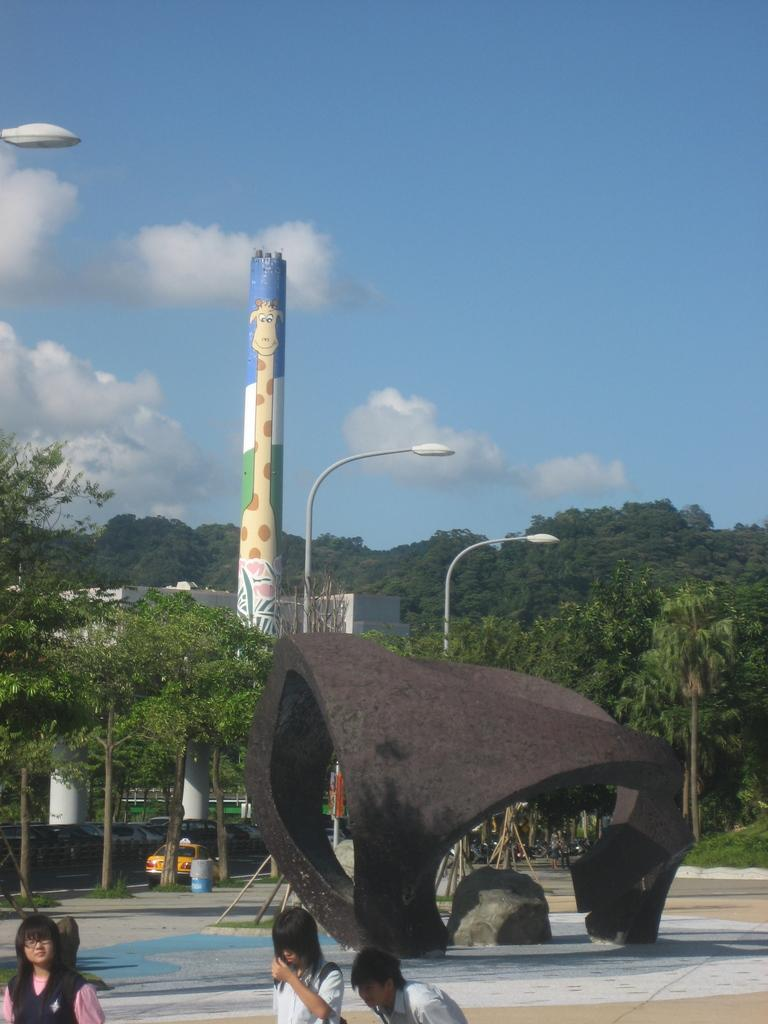What can be seen in the left corner of the image? There are people standing in the left corner of the image. What structures are visible in the background of the image? There is a tower and a building in the background of the image. What type of vegetation is present in the background of the image? There are trees in the background of the image. What is the color of the object located in the left top corner of the image? There is a white color object in the left top corner of the image. What flavor of surprise can be seen in the image? There is no surprise present in the image, and therefore no flavor can be associated with it. 